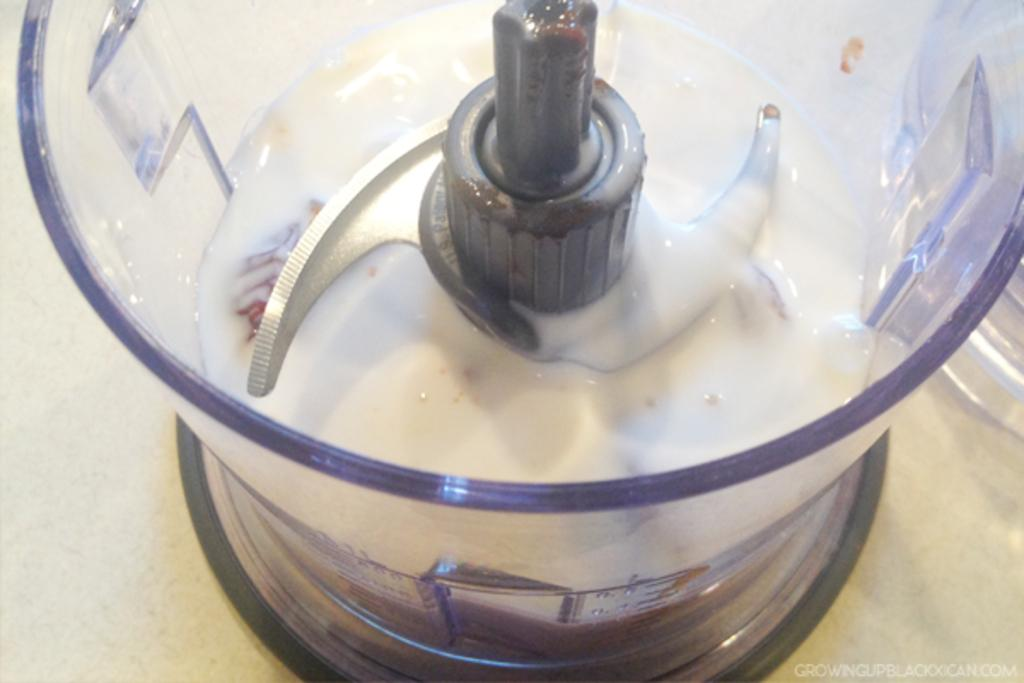What appliance is visible in the image? There is a juicer in the image. What is inside the juicer? The juicer contains a white liquid. Where is the juicer located? The juicer is on a surface. What additional information can be found in the image? There is text in the bottom right corner of the image. How many ants are crawling on the surface of the juicer in the image? There are no ants visible in the image; the focus is on the juicer and its contents. 